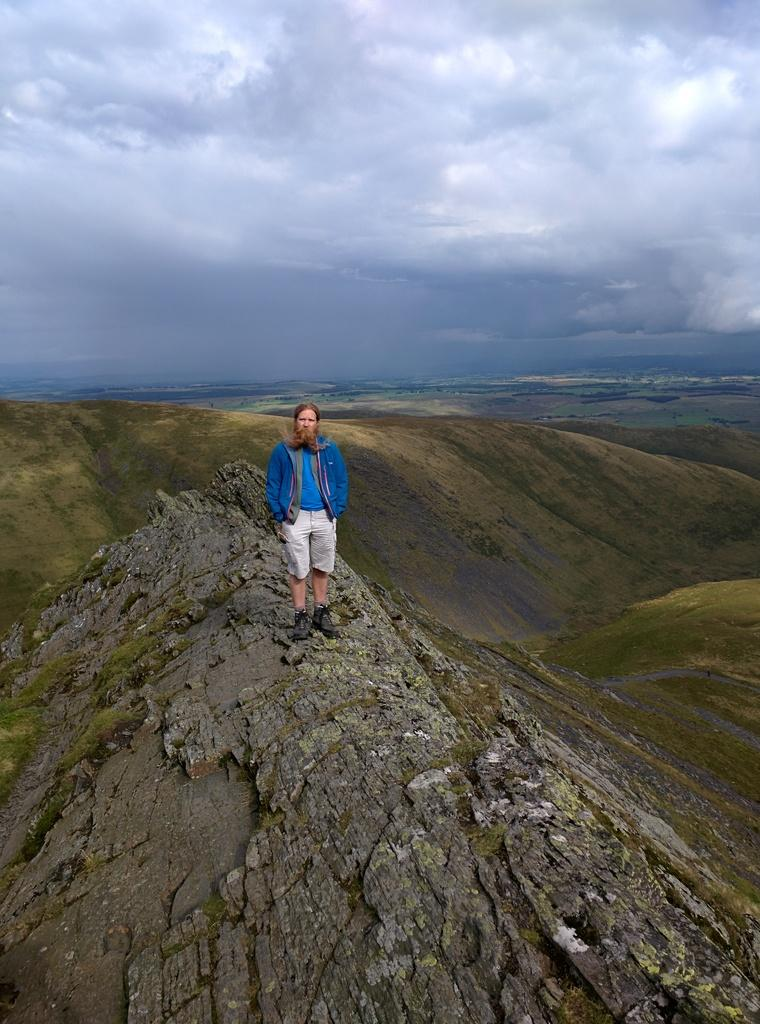Who is present in the image? There is a man standing in the image. Where is the man located? The man is standing on a mountain. What can be seen in the background of the image? There are mountains and the sky visible in the background of the image. What type of card is the man holding in the image? There is no card present in the image; the man is standing on a mountain with no visible objects in his hands. 